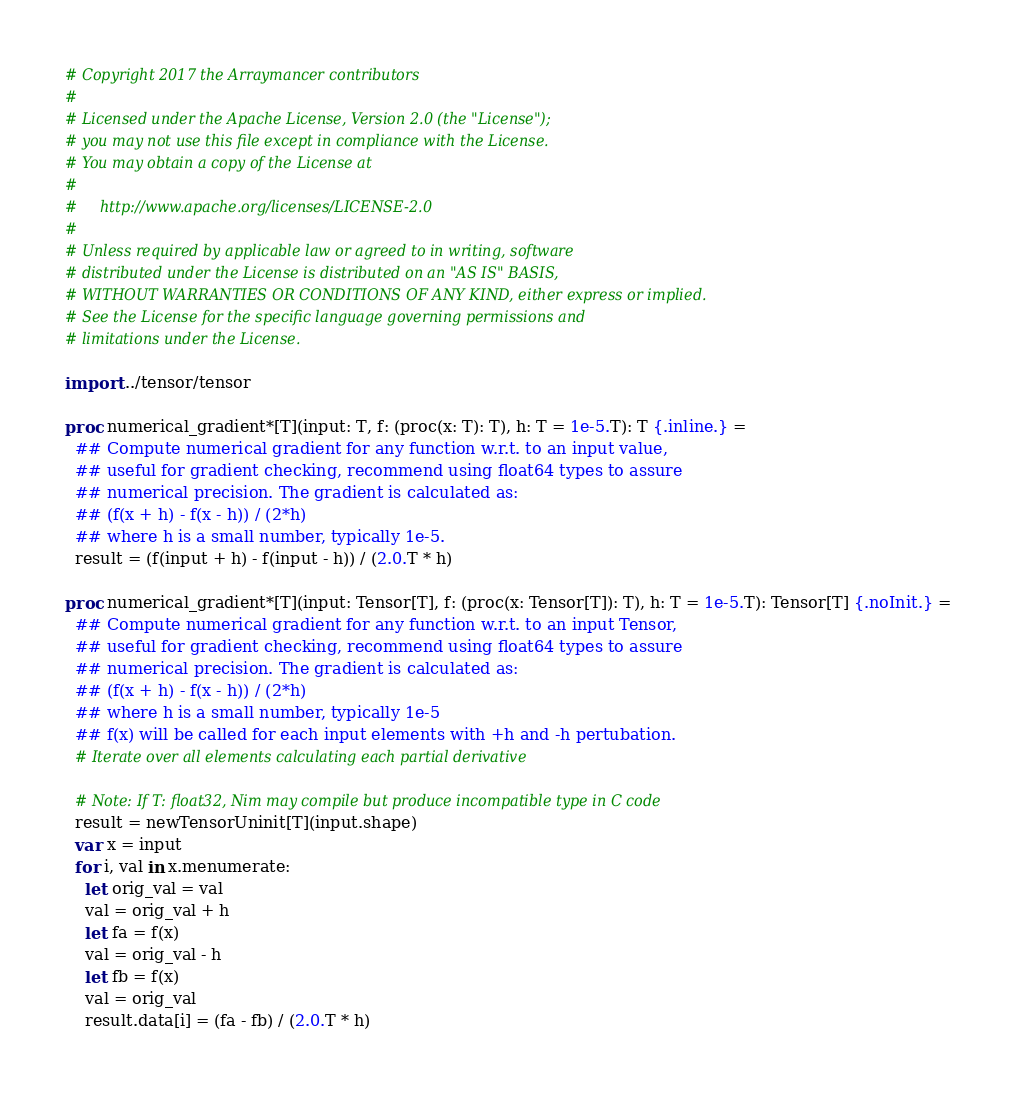<code> <loc_0><loc_0><loc_500><loc_500><_Nim_># Copyright 2017 the Arraymancer contributors
#
# Licensed under the Apache License, Version 2.0 (the "License");
# you may not use this file except in compliance with the License.
# You may obtain a copy of the License at
#
#     http://www.apache.org/licenses/LICENSE-2.0
#
# Unless required by applicable law or agreed to in writing, software
# distributed under the License is distributed on an "AS IS" BASIS,
# WITHOUT WARRANTIES OR CONDITIONS OF ANY KIND, either express or implied.
# See the License for the specific language governing permissions and
# limitations under the License.

import ../tensor/tensor

proc numerical_gradient*[T](input: T, f: (proc(x: T): T), h: T = 1e-5.T): T {.inline.} =
  ## Compute numerical gradient for any function w.r.t. to an input value,
  ## useful for gradient checking, recommend using float64 types to assure
  ## numerical precision. The gradient is calculated as:
  ## (f(x + h) - f(x - h)) / (2*h)
  ## where h is a small number, typically 1e-5.
  result = (f(input + h) - f(input - h)) / (2.0.T * h)

proc numerical_gradient*[T](input: Tensor[T], f: (proc(x: Tensor[T]): T), h: T = 1e-5.T): Tensor[T] {.noInit.} =
  ## Compute numerical gradient for any function w.r.t. to an input Tensor,
  ## useful for gradient checking, recommend using float64 types to assure
  ## numerical precision. The gradient is calculated as:
  ## (f(x + h) - f(x - h)) / (2*h)
  ## where h is a small number, typically 1e-5
  ## f(x) will be called for each input elements with +h and -h pertubation.
  # Iterate over all elements calculating each partial derivative

  # Note: If T: float32, Nim may compile but produce incompatible type in C code
  result = newTensorUninit[T](input.shape)
  var x = input
  for i, val in x.menumerate:
    let orig_val = val
    val = orig_val + h
    let fa = f(x)
    val = orig_val - h
    let fb = f(x)
    val = orig_val
    result.data[i] = (fa - fb) / (2.0.T * h)
</code> 